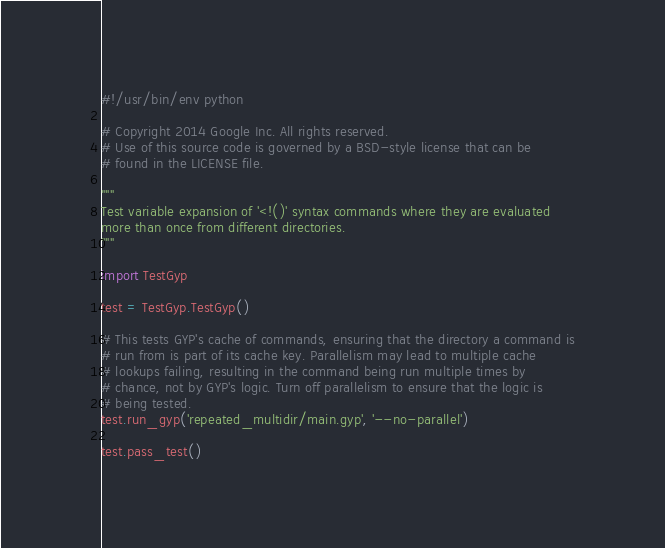<code> <loc_0><loc_0><loc_500><loc_500><_Python_>#!/usr/bin/env python

# Copyright 2014 Google Inc. All rights reserved.
# Use of this source code is governed by a BSD-style license that can be
# found in the LICENSE file.

"""
Test variable expansion of '<!()' syntax commands where they are evaluated
more than once from different directories.
"""

import TestGyp

test = TestGyp.TestGyp()

# This tests GYP's cache of commands, ensuring that the directory a command is
# run from is part of its cache key. Parallelism may lead to multiple cache
# lookups failing, resulting in the command being run multiple times by
# chance, not by GYP's logic. Turn off parallelism to ensure that the logic is
# being tested.
test.run_gyp('repeated_multidir/main.gyp', '--no-parallel')

test.pass_test()
</code> 